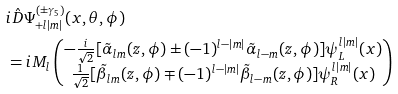<formula> <loc_0><loc_0><loc_500><loc_500>& i \hat { D } \Psi _ { + l | m | } ^ { ( \pm \gamma _ { 5 } ) } ( x , \theta , \phi ) \\ & = i M _ { l } \begin{pmatrix} - \frac { i } { \sqrt { 2 } } [ \tilde { \alpha } _ { l m } ( z , \phi ) \pm ( - 1 ) ^ { l - | m | } \tilde { \alpha } _ { l - m } ( z , \phi ) ] \psi _ { L } ^ { l | m | } ( x ) \\ \frac { 1 } { \sqrt { 2 } } [ \tilde { \beta } _ { l m } ( z , \phi ) \mp ( - 1 ) ^ { l - | m | } \tilde { \beta } _ { l - m } ( z , \phi ) ] \psi _ { R } ^ { l | m | } ( x ) \end{pmatrix}</formula> 